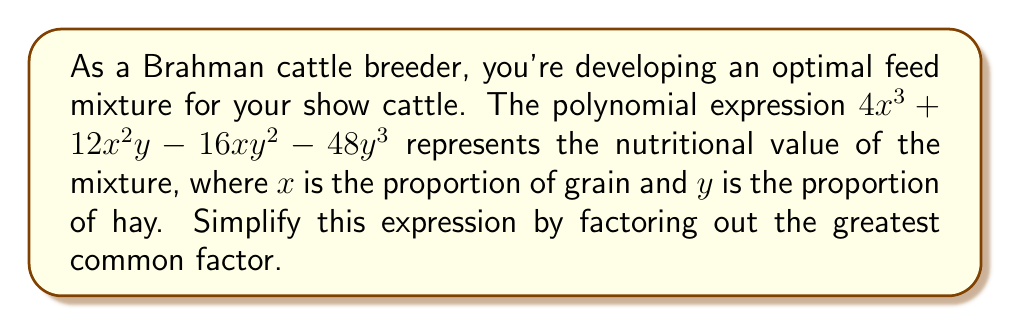Solve this math problem. To simplify this polynomial expression, we need to factor out the greatest common factor (GCF). Let's approach this step-by-step:

1) First, identify the terms in the polynomial:
   $4x^3$, $12x^2y$, $-16xy^2$, and $-48y^3$

2) Find the GCF of the coefficients:
   GCF of 4, 12, -16, and -48 is 4

3) Find the GCF of the variables:
   The lowest power of $x$ is 0 (in the last term)
   The lowest power of $y$ is 0 (in the first term)
   So, there are no common variables to factor out

4) The overall GCF is 4

5) Factor out the GCF:
   $$4x^3 + 12x^2y - 16xy^2 - 48y^3$$
   $$= 4(x^3 + 3x^2y - 4xy^2 - 12y^3)$$

6) The expression inside the parentheses cannot be factored further

Therefore, the simplified expression is $4(x^3 + 3x^2y - 4xy^2 - 12y^3)$.
Answer: $4(x^3 + 3x^2y - 4xy^2 - 12y^3)$ 